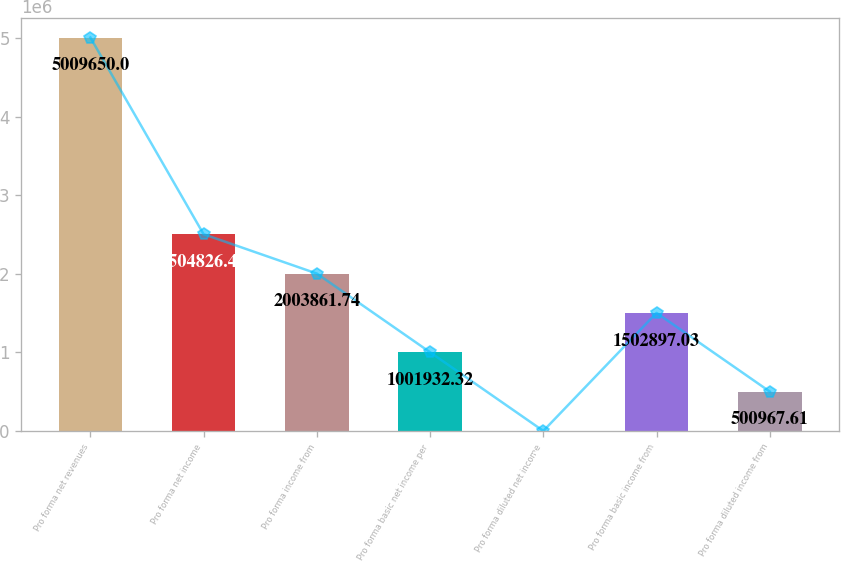Convert chart. <chart><loc_0><loc_0><loc_500><loc_500><bar_chart><fcel>Pro forma net revenues<fcel>Pro forma net income<fcel>Pro forma income from<fcel>Pro forma basic net income per<fcel>Pro forma diluted net income<fcel>Pro forma basic income from<fcel>Pro forma diluted income from<nl><fcel>5.00965e+06<fcel>2.50483e+06<fcel>2.00386e+06<fcel>1.00193e+06<fcel>2.9<fcel>1.5029e+06<fcel>500968<nl></chart> 